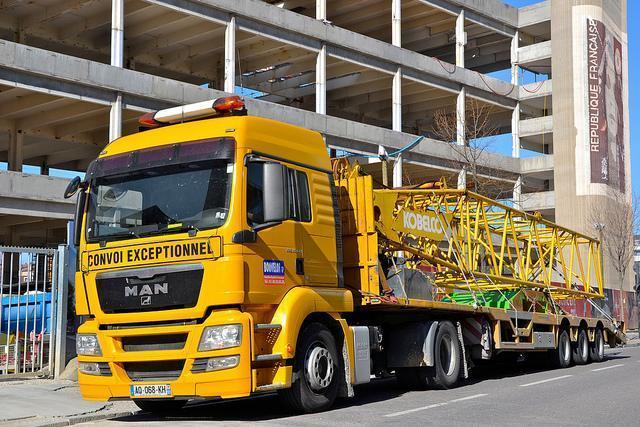How many tires can you see?
Give a very brief answer. 5. 